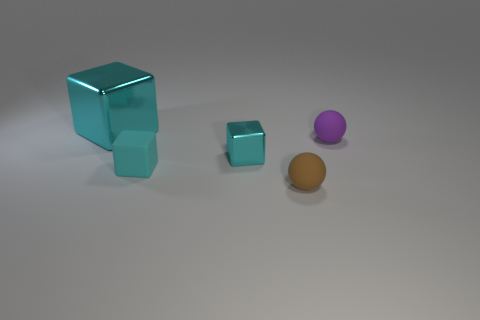Does the tiny rubber block have the same color as the rubber object that is right of the small brown matte object?
Your response must be concise. No. Is there any other thing that is made of the same material as the brown object?
Keep it short and to the point. Yes. What is the shape of the small purple rubber thing?
Give a very brief answer. Sphere. How big is the shiny thing on the right side of the cyan metallic cube to the left of the cyan rubber cube?
Offer a terse response. Small. Is the number of cyan things that are right of the small shiny object the same as the number of cyan matte things behind the cyan rubber cube?
Give a very brief answer. Yes. There is a tiny object that is both behind the cyan matte thing and on the right side of the small shiny block; what is it made of?
Provide a succinct answer. Rubber. There is a cyan rubber block; is its size the same as the shiny object left of the tiny cyan matte object?
Provide a short and direct response. No. How many other things are the same color as the small shiny block?
Your response must be concise. 2. Is the number of big metallic cubes that are in front of the large metallic block greater than the number of tiny metal things?
Your answer should be very brief. No. The metallic block behind the tiny purple rubber thing to the right of the small rubber thing to the left of the tiny brown sphere is what color?
Offer a very short reply. Cyan. 